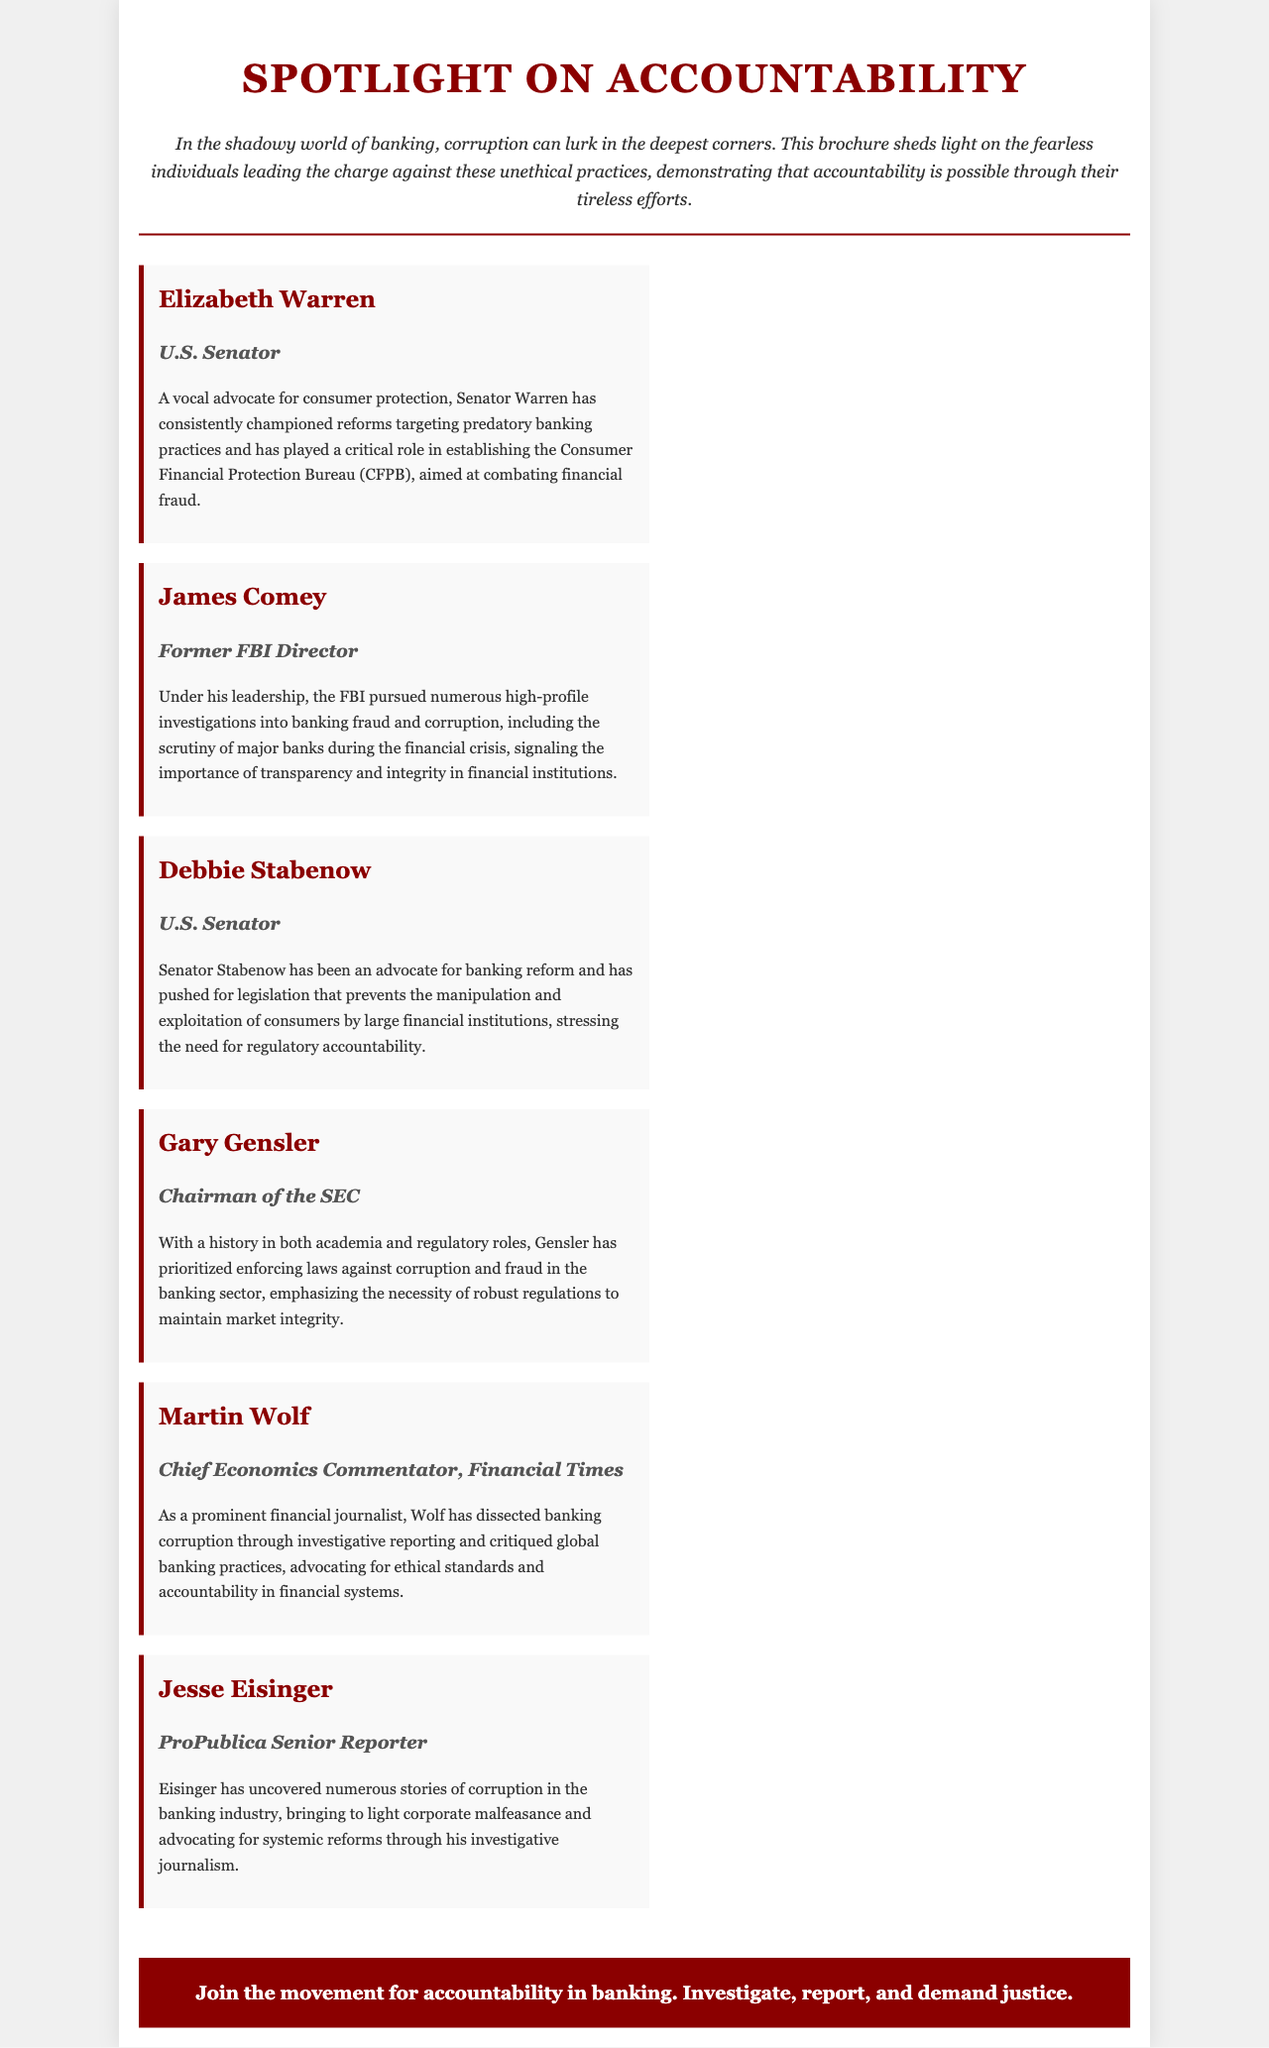What is the title of the brochure? The title of the brochure is prominently displayed at the top of the document.
Answer: Spotlight on Accountability Who is a U.S. Senator known for consumer protection? The profile section includes specific figures, one of whom is recognized for advocating consumer protection.
Answer: Elizabeth Warren What organization did Elizabeth Warren help establish? The document mentions a specific organization tied to Senator Warren's efforts in consumer protection.
Answer: Consumer Financial Protection Bureau Who is the Chairman of the SEC? The document lists specific individuals involved in the fight against banking corruption, including a regulatory leader.
Answer: Gary Gensler What role did James Comey hold? One of the profiles describes his previous title as a key figure in investigations related to banking.
Answer: Former FBI Director Which figure is associated with ProPublica? The document profiles several individuals, one of whom works for a well-known journalistic organization.
Answer: Jesse Eisinger What is the primary call to action in the brochure? The bottom section of the brochure encourages specific actions from the reader.
Answer: Join the movement for accountability in banking How many profiles are mentioned in the brochure? The profiles section showcases several individuals, which can be counted for the total.
Answer: Six 